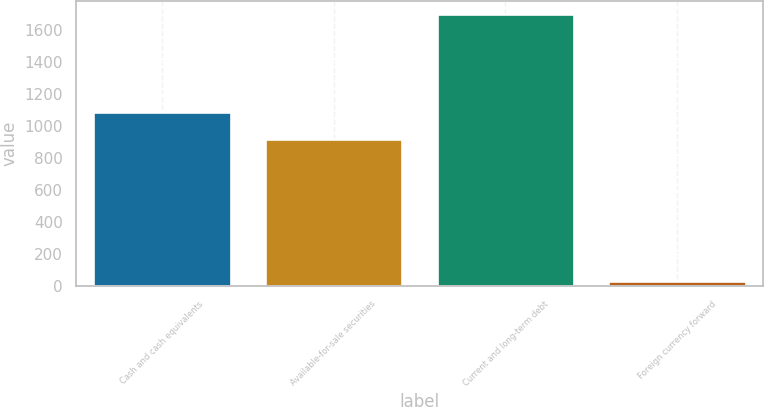<chart> <loc_0><loc_0><loc_500><loc_500><bar_chart><fcel>Cash and cash equivalents<fcel>Available-for-sale securities<fcel>Current and long-term debt<fcel>Foreign currency forward<nl><fcel>1084.07<fcel>917.8<fcel>1697.5<fcel>34.8<nl></chart> 